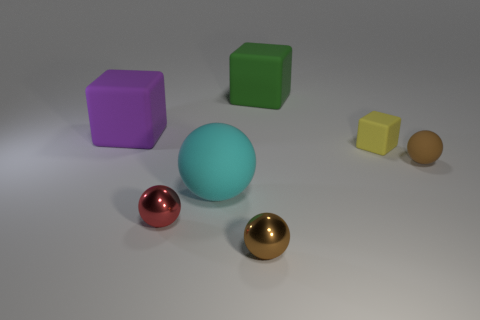Subtract all gray balls. Subtract all brown cylinders. How many balls are left? 4 Add 2 big blue balls. How many objects exist? 9 Subtract all blocks. How many objects are left? 4 Subtract all yellow things. Subtract all tiny metallic things. How many objects are left? 4 Add 4 large objects. How many large objects are left? 7 Add 5 tiny objects. How many tiny objects exist? 9 Subtract 1 green blocks. How many objects are left? 6 